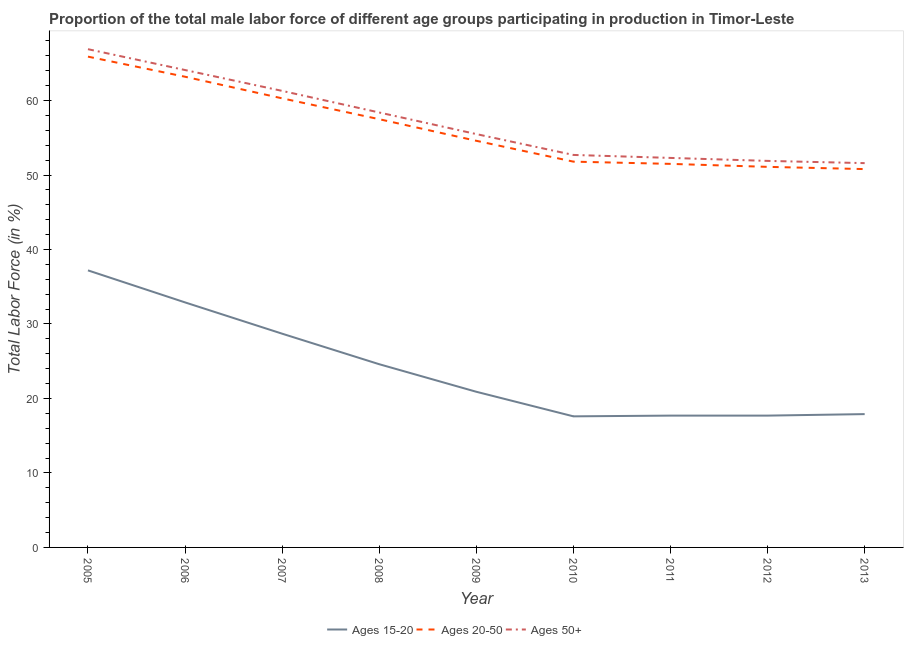Does the line corresponding to percentage of male labor force within the age group 20-50 intersect with the line corresponding to percentage of male labor force above age 50?
Your answer should be very brief. No. What is the percentage of male labor force within the age group 15-20 in 2013?
Provide a short and direct response. 17.9. Across all years, what is the maximum percentage of male labor force above age 50?
Your answer should be compact. 66.9. Across all years, what is the minimum percentage of male labor force above age 50?
Offer a terse response. 51.6. In which year was the percentage of male labor force within the age group 15-20 maximum?
Ensure brevity in your answer.  2005. In which year was the percentage of male labor force above age 50 minimum?
Make the answer very short. 2013. What is the total percentage of male labor force within the age group 15-20 in the graph?
Offer a very short reply. 215.2. What is the difference between the percentage of male labor force within the age group 15-20 in 2006 and that in 2010?
Your response must be concise. 15.3. What is the difference between the percentage of male labor force above age 50 in 2007 and the percentage of male labor force within the age group 15-20 in 2009?
Your answer should be very brief. 40.4. What is the average percentage of male labor force within the age group 15-20 per year?
Your answer should be compact. 23.91. In the year 2011, what is the difference between the percentage of male labor force above age 50 and percentage of male labor force within the age group 15-20?
Give a very brief answer. 34.6. What is the ratio of the percentage of male labor force above age 50 in 2008 to that in 2009?
Make the answer very short. 1.05. Is the percentage of male labor force above age 50 in 2005 less than that in 2006?
Give a very brief answer. No. What is the difference between the highest and the second highest percentage of male labor force within the age group 15-20?
Give a very brief answer. 4.3. What is the difference between the highest and the lowest percentage of male labor force above age 50?
Your answer should be very brief. 15.3. Is the percentage of male labor force within the age group 20-50 strictly greater than the percentage of male labor force within the age group 15-20 over the years?
Your response must be concise. Yes. How many lines are there?
Offer a terse response. 3. What is the difference between two consecutive major ticks on the Y-axis?
Make the answer very short. 10. Are the values on the major ticks of Y-axis written in scientific E-notation?
Your answer should be compact. No. Does the graph contain grids?
Offer a terse response. No. What is the title of the graph?
Ensure brevity in your answer.  Proportion of the total male labor force of different age groups participating in production in Timor-Leste. What is the Total Labor Force (in %) in Ages 15-20 in 2005?
Make the answer very short. 37.2. What is the Total Labor Force (in %) in Ages 20-50 in 2005?
Keep it short and to the point. 65.9. What is the Total Labor Force (in %) in Ages 50+ in 2005?
Offer a very short reply. 66.9. What is the Total Labor Force (in %) in Ages 15-20 in 2006?
Provide a succinct answer. 32.9. What is the Total Labor Force (in %) of Ages 20-50 in 2006?
Provide a short and direct response. 63.2. What is the Total Labor Force (in %) in Ages 50+ in 2006?
Provide a succinct answer. 64.1. What is the Total Labor Force (in %) of Ages 15-20 in 2007?
Keep it short and to the point. 28.7. What is the Total Labor Force (in %) in Ages 20-50 in 2007?
Keep it short and to the point. 60.3. What is the Total Labor Force (in %) of Ages 50+ in 2007?
Ensure brevity in your answer.  61.3. What is the Total Labor Force (in %) in Ages 15-20 in 2008?
Provide a short and direct response. 24.6. What is the Total Labor Force (in %) in Ages 20-50 in 2008?
Offer a very short reply. 57.5. What is the Total Labor Force (in %) of Ages 50+ in 2008?
Make the answer very short. 58.4. What is the Total Labor Force (in %) in Ages 15-20 in 2009?
Your answer should be very brief. 20.9. What is the Total Labor Force (in %) of Ages 20-50 in 2009?
Ensure brevity in your answer.  54.6. What is the Total Labor Force (in %) of Ages 50+ in 2009?
Offer a very short reply. 55.5. What is the Total Labor Force (in %) of Ages 15-20 in 2010?
Keep it short and to the point. 17.6. What is the Total Labor Force (in %) in Ages 20-50 in 2010?
Give a very brief answer. 51.8. What is the Total Labor Force (in %) in Ages 50+ in 2010?
Your answer should be very brief. 52.7. What is the Total Labor Force (in %) in Ages 15-20 in 2011?
Your answer should be compact. 17.7. What is the Total Labor Force (in %) of Ages 20-50 in 2011?
Your answer should be very brief. 51.5. What is the Total Labor Force (in %) in Ages 50+ in 2011?
Your answer should be compact. 52.3. What is the Total Labor Force (in %) in Ages 15-20 in 2012?
Keep it short and to the point. 17.7. What is the Total Labor Force (in %) of Ages 20-50 in 2012?
Keep it short and to the point. 51.1. What is the Total Labor Force (in %) of Ages 50+ in 2012?
Your answer should be very brief. 51.9. What is the Total Labor Force (in %) in Ages 15-20 in 2013?
Offer a very short reply. 17.9. What is the Total Labor Force (in %) in Ages 20-50 in 2013?
Your answer should be very brief. 50.8. What is the Total Labor Force (in %) of Ages 50+ in 2013?
Ensure brevity in your answer.  51.6. Across all years, what is the maximum Total Labor Force (in %) in Ages 15-20?
Offer a terse response. 37.2. Across all years, what is the maximum Total Labor Force (in %) in Ages 20-50?
Offer a very short reply. 65.9. Across all years, what is the maximum Total Labor Force (in %) in Ages 50+?
Give a very brief answer. 66.9. Across all years, what is the minimum Total Labor Force (in %) in Ages 15-20?
Provide a succinct answer. 17.6. Across all years, what is the minimum Total Labor Force (in %) of Ages 20-50?
Keep it short and to the point. 50.8. Across all years, what is the minimum Total Labor Force (in %) in Ages 50+?
Give a very brief answer. 51.6. What is the total Total Labor Force (in %) of Ages 15-20 in the graph?
Your answer should be very brief. 215.2. What is the total Total Labor Force (in %) in Ages 20-50 in the graph?
Provide a succinct answer. 506.7. What is the total Total Labor Force (in %) of Ages 50+ in the graph?
Give a very brief answer. 514.7. What is the difference between the Total Labor Force (in %) of Ages 20-50 in 2005 and that in 2006?
Your answer should be compact. 2.7. What is the difference between the Total Labor Force (in %) of Ages 15-20 in 2005 and that in 2007?
Your answer should be very brief. 8.5. What is the difference between the Total Labor Force (in %) of Ages 50+ in 2005 and that in 2007?
Give a very brief answer. 5.6. What is the difference between the Total Labor Force (in %) in Ages 15-20 in 2005 and that in 2008?
Offer a very short reply. 12.6. What is the difference between the Total Labor Force (in %) of Ages 20-50 in 2005 and that in 2008?
Provide a short and direct response. 8.4. What is the difference between the Total Labor Force (in %) of Ages 50+ in 2005 and that in 2008?
Offer a very short reply. 8.5. What is the difference between the Total Labor Force (in %) of Ages 15-20 in 2005 and that in 2009?
Your answer should be compact. 16.3. What is the difference between the Total Labor Force (in %) in Ages 15-20 in 2005 and that in 2010?
Offer a very short reply. 19.6. What is the difference between the Total Labor Force (in %) in Ages 15-20 in 2005 and that in 2011?
Your answer should be very brief. 19.5. What is the difference between the Total Labor Force (in %) of Ages 20-50 in 2005 and that in 2011?
Make the answer very short. 14.4. What is the difference between the Total Labor Force (in %) of Ages 50+ in 2005 and that in 2011?
Make the answer very short. 14.6. What is the difference between the Total Labor Force (in %) in Ages 15-20 in 2005 and that in 2012?
Give a very brief answer. 19.5. What is the difference between the Total Labor Force (in %) of Ages 20-50 in 2005 and that in 2012?
Offer a terse response. 14.8. What is the difference between the Total Labor Force (in %) of Ages 50+ in 2005 and that in 2012?
Make the answer very short. 15. What is the difference between the Total Labor Force (in %) in Ages 15-20 in 2005 and that in 2013?
Your response must be concise. 19.3. What is the difference between the Total Labor Force (in %) of Ages 15-20 in 2006 and that in 2007?
Provide a short and direct response. 4.2. What is the difference between the Total Labor Force (in %) in Ages 20-50 in 2006 and that in 2007?
Keep it short and to the point. 2.9. What is the difference between the Total Labor Force (in %) of Ages 50+ in 2006 and that in 2007?
Offer a very short reply. 2.8. What is the difference between the Total Labor Force (in %) in Ages 20-50 in 2006 and that in 2009?
Make the answer very short. 8.6. What is the difference between the Total Labor Force (in %) in Ages 50+ in 2006 and that in 2009?
Your answer should be compact. 8.6. What is the difference between the Total Labor Force (in %) in Ages 15-20 in 2006 and that in 2010?
Give a very brief answer. 15.3. What is the difference between the Total Labor Force (in %) of Ages 20-50 in 2006 and that in 2010?
Your answer should be very brief. 11.4. What is the difference between the Total Labor Force (in %) of Ages 15-20 in 2006 and that in 2011?
Make the answer very short. 15.2. What is the difference between the Total Labor Force (in %) in Ages 15-20 in 2006 and that in 2012?
Make the answer very short. 15.2. What is the difference between the Total Labor Force (in %) of Ages 20-50 in 2006 and that in 2012?
Make the answer very short. 12.1. What is the difference between the Total Labor Force (in %) of Ages 50+ in 2006 and that in 2012?
Your answer should be very brief. 12.2. What is the difference between the Total Labor Force (in %) in Ages 15-20 in 2007 and that in 2008?
Provide a short and direct response. 4.1. What is the difference between the Total Labor Force (in %) in Ages 15-20 in 2007 and that in 2009?
Your response must be concise. 7.8. What is the difference between the Total Labor Force (in %) in Ages 15-20 in 2007 and that in 2010?
Offer a terse response. 11.1. What is the difference between the Total Labor Force (in %) in Ages 20-50 in 2007 and that in 2010?
Make the answer very short. 8.5. What is the difference between the Total Labor Force (in %) in Ages 50+ in 2007 and that in 2010?
Your response must be concise. 8.6. What is the difference between the Total Labor Force (in %) in Ages 20-50 in 2007 and that in 2011?
Provide a short and direct response. 8.8. What is the difference between the Total Labor Force (in %) in Ages 50+ in 2007 and that in 2011?
Ensure brevity in your answer.  9. What is the difference between the Total Labor Force (in %) in Ages 15-20 in 2007 and that in 2012?
Your answer should be compact. 11. What is the difference between the Total Labor Force (in %) of Ages 50+ in 2007 and that in 2012?
Provide a short and direct response. 9.4. What is the difference between the Total Labor Force (in %) in Ages 20-50 in 2007 and that in 2013?
Ensure brevity in your answer.  9.5. What is the difference between the Total Labor Force (in %) of Ages 50+ in 2007 and that in 2013?
Offer a terse response. 9.7. What is the difference between the Total Labor Force (in %) of Ages 15-20 in 2008 and that in 2009?
Keep it short and to the point. 3.7. What is the difference between the Total Labor Force (in %) of Ages 20-50 in 2008 and that in 2009?
Provide a short and direct response. 2.9. What is the difference between the Total Labor Force (in %) in Ages 20-50 in 2008 and that in 2011?
Your answer should be very brief. 6. What is the difference between the Total Labor Force (in %) in Ages 20-50 in 2008 and that in 2012?
Your response must be concise. 6.4. What is the difference between the Total Labor Force (in %) of Ages 50+ in 2008 and that in 2012?
Your response must be concise. 6.5. What is the difference between the Total Labor Force (in %) in Ages 20-50 in 2008 and that in 2013?
Your answer should be very brief. 6.7. What is the difference between the Total Labor Force (in %) of Ages 50+ in 2008 and that in 2013?
Ensure brevity in your answer.  6.8. What is the difference between the Total Labor Force (in %) in Ages 20-50 in 2009 and that in 2010?
Keep it short and to the point. 2.8. What is the difference between the Total Labor Force (in %) of Ages 20-50 in 2009 and that in 2013?
Your answer should be compact. 3.8. What is the difference between the Total Labor Force (in %) of Ages 50+ in 2009 and that in 2013?
Your answer should be very brief. 3.9. What is the difference between the Total Labor Force (in %) in Ages 20-50 in 2010 and that in 2011?
Offer a very short reply. 0.3. What is the difference between the Total Labor Force (in %) of Ages 15-20 in 2010 and that in 2012?
Your answer should be very brief. -0.1. What is the difference between the Total Labor Force (in %) of Ages 50+ in 2010 and that in 2012?
Your answer should be compact. 0.8. What is the difference between the Total Labor Force (in %) in Ages 20-50 in 2010 and that in 2013?
Offer a very short reply. 1. What is the difference between the Total Labor Force (in %) of Ages 15-20 in 2011 and that in 2013?
Your answer should be very brief. -0.2. What is the difference between the Total Labor Force (in %) of Ages 20-50 in 2012 and that in 2013?
Offer a very short reply. 0.3. What is the difference between the Total Labor Force (in %) of Ages 50+ in 2012 and that in 2013?
Keep it short and to the point. 0.3. What is the difference between the Total Labor Force (in %) of Ages 15-20 in 2005 and the Total Labor Force (in %) of Ages 20-50 in 2006?
Keep it short and to the point. -26. What is the difference between the Total Labor Force (in %) in Ages 15-20 in 2005 and the Total Labor Force (in %) in Ages 50+ in 2006?
Make the answer very short. -26.9. What is the difference between the Total Labor Force (in %) in Ages 15-20 in 2005 and the Total Labor Force (in %) in Ages 20-50 in 2007?
Give a very brief answer. -23.1. What is the difference between the Total Labor Force (in %) in Ages 15-20 in 2005 and the Total Labor Force (in %) in Ages 50+ in 2007?
Your response must be concise. -24.1. What is the difference between the Total Labor Force (in %) of Ages 15-20 in 2005 and the Total Labor Force (in %) of Ages 20-50 in 2008?
Offer a terse response. -20.3. What is the difference between the Total Labor Force (in %) in Ages 15-20 in 2005 and the Total Labor Force (in %) in Ages 50+ in 2008?
Offer a very short reply. -21.2. What is the difference between the Total Labor Force (in %) in Ages 20-50 in 2005 and the Total Labor Force (in %) in Ages 50+ in 2008?
Give a very brief answer. 7.5. What is the difference between the Total Labor Force (in %) of Ages 15-20 in 2005 and the Total Labor Force (in %) of Ages 20-50 in 2009?
Your response must be concise. -17.4. What is the difference between the Total Labor Force (in %) of Ages 15-20 in 2005 and the Total Labor Force (in %) of Ages 50+ in 2009?
Offer a terse response. -18.3. What is the difference between the Total Labor Force (in %) in Ages 20-50 in 2005 and the Total Labor Force (in %) in Ages 50+ in 2009?
Offer a very short reply. 10.4. What is the difference between the Total Labor Force (in %) in Ages 15-20 in 2005 and the Total Labor Force (in %) in Ages 20-50 in 2010?
Give a very brief answer. -14.6. What is the difference between the Total Labor Force (in %) of Ages 15-20 in 2005 and the Total Labor Force (in %) of Ages 50+ in 2010?
Your answer should be very brief. -15.5. What is the difference between the Total Labor Force (in %) of Ages 20-50 in 2005 and the Total Labor Force (in %) of Ages 50+ in 2010?
Provide a succinct answer. 13.2. What is the difference between the Total Labor Force (in %) in Ages 15-20 in 2005 and the Total Labor Force (in %) in Ages 20-50 in 2011?
Provide a short and direct response. -14.3. What is the difference between the Total Labor Force (in %) in Ages 15-20 in 2005 and the Total Labor Force (in %) in Ages 50+ in 2011?
Give a very brief answer. -15.1. What is the difference between the Total Labor Force (in %) in Ages 15-20 in 2005 and the Total Labor Force (in %) in Ages 20-50 in 2012?
Provide a succinct answer. -13.9. What is the difference between the Total Labor Force (in %) of Ages 15-20 in 2005 and the Total Labor Force (in %) of Ages 50+ in 2012?
Your answer should be compact. -14.7. What is the difference between the Total Labor Force (in %) of Ages 20-50 in 2005 and the Total Labor Force (in %) of Ages 50+ in 2012?
Ensure brevity in your answer.  14. What is the difference between the Total Labor Force (in %) of Ages 15-20 in 2005 and the Total Labor Force (in %) of Ages 50+ in 2013?
Keep it short and to the point. -14.4. What is the difference between the Total Labor Force (in %) in Ages 15-20 in 2006 and the Total Labor Force (in %) in Ages 20-50 in 2007?
Your answer should be compact. -27.4. What is the difference between the Total Labor Force (in %) of Ages 15-20 in 2006 and the Total Labor Force (in %) of Ages 50+ in 2007?
Your response must be concise. -28.4. What is the difference between the Total Labor Force (in %) of Ages 15-20 in 2006 and the Total Labor Force (in %) of Ages 20-50 in 2008?
Your answer should be compact. -24.6. What is the difference between the Total Labor Force (in %) in Ages 15-20 in 2006 and the Total Labor Force (in %) in Ages 50+ in 2008?
Ensure brevity in your answer.  -25.5. What is the difference between the Total Labor Force (in %) of Ages 15-20 in 2006 and the Total Labor Force (in %) of Ages 20-50 in 2009?
Offer a very short reply. -21.7. What is the difference between the Total Labor Force (in %) of Ages 15-20 in 2006 and the Total Labor Force (in %) of Ages 50+ in 2009?
Offer a terse response. -22.6. What is the difference between the Total Labor Force (in %) of Ages 20-50 in 2006 and the Total Labor Force (in %) of Ages 50+ in 2009?
Your response must be concise. 7.7. What is the difference between the Total Labor Force (in %) in Ages 15-20 in 2006 and the Total Labor Force (in %) in Ages 20-50 in 2010?
Your answer should be compact. -18.9. What is the difference between the Total Labor Force (in %) of Ages 15-20 in 2006 and the Total Labor Force (in %) of Ages 50+ in 2010?
Your response must be concise. -19.8. What is the difference between the Total Labor Force (in %) in Ages 15-20 in 2006 and the Total Labor Force (in %) in Ages 20-50 in 2011?
Give a very brief answer. -18.6. What is the difference between the Total Labor Force (in %) of Ages 15-20 in 2006 and the Total Labor Force (in %) of Ages 50+ in 2011?
Offer a very short reply. -19.4. What is the difference between the Total Labor Force (in %) in Ages 15-20 in 2006 and the Total Labor Force (in %) in Ages 20-50 in 2012?
Your answer should be very brief. -18.2. What is the difference between the Total Labor Force (in %) in Ages 20-50 in 2006 and the Total Labor Force (in %) in Ages 50+ in 2012?
Offer a very short reply. 11.3. What is the difference between the Total Labor Force (in %) in Ages 15-20 in 2006 and the Total Labor Force (in %) in Ages 20-50 in 2013?
Provide a short and direct response. -17.9. What is the difference between the Total Labor Force (in %) of Ages 15-20 in 2006 and the Total Labor Force (in %) of Ages 50+ in 2013?
Keep it short and to the point. -18.7. What is the difference between the Total Labor Force (in %) of Ages 20-50 in 2006 and the Total Labor Force (in %) of Ages 50+ in 2013?
Make the answer very short. 11.6. What is the difference between the Total Labor Force (in %) in Ages 15-20 in 2007 and the Total Labor Force (in %) in Ages 20-50 in 2008?
Your answer should be very brief. -28.8. What is the difference between the Total Labor Force (in %) of Ages 15-20 in 2007 and the Total Labor Force (in %) of Ages 50+ in 2008?
Your answer should be very brief. -29.7. What is the difference between the Total Labor Force (in %) of Ages 15-20 in 2007 and the Total Labor Force (in %) of Ages 20-50 in 2009?
Your answer should be very brief. -25.9. What is the difference between the Total Labor Force (in %) in Ages 15-20 in 2007 and the Total Labor Force (in %) in Ages 50+ in 2009?
Make the answer very short. -26.8. What is the difference between the Total Labor Force (in %) in Ages 15-20 in 2007 and the Total Labor Force (in %) in Ages 20-50 in 2010?
Ensure brevity in your answer.  -23.1. What is the difference between the Total Labor Force (in %) in Ages 15-20 in 2007 and the Total Labor Force (in %) in Ages 50+ in 2010?
Provide a short and direct response. -24. What is the difference between the Total Labor Force (in %) of Ages 15-20 in 2007 and the Total Labor Force (in %) of Ages 20-50 in 2011?
Give a very brief answer. -22.8. What is the difference between the Total Labor Force (in %) of Ages 15-20 in 2007 and the Total Labor Force (in %) of Ages 50+ in 2011?
Give a very brief answer. -23.6. What is the difference between the Total Labor Force (in %) in Ages 15-20 in 2007 and the Total Labor Force (in %) in Ages 20-50 in 2012?
Provide a succinct answer. -22.4. What is the difference between the Total Labor Force (in %) of Ages 15-20 in 2007 and the Total Labor Force (in %) of Ages 50+ in 2012?
Your answer should be compact. -23.2. What is the difference between the Total Labor Force (in %) of Ages 15-20 in 2007 and the Total Labor Force (in %) of Ages 20-50 in 2013?
Offer a terse response. -22.1. What is the difference between the Total Labor Force (in %) of Ages 15-20 in 2007 and the Total Labor Force (in %) of Ages 50+ in 2013?
Offer a terse response. -22.9. What is the difference between the Total Labor Force (in %) in Ages 15-20 in 2008 and the Total Labor Force (in %) in Ages 50+ in 2009?
Your response must be concise. -30.9. What is the difference between the Total Labor Force (in %) of Ages 15-20 in 2008 and the Total Labor Force (in %) of Ages 20-50 in 2010?
Give a very brief answer. -27.2. What is the difference between the Total Labor Force (in %) of Ages 15-20 in 2008 and the Total Labor Force (in %) of Ages 50+ in 2010?
Offer a very short reply. -28.1. What is the difference between the Total Labor Force (in %) in Ages 15-20 in 2008 and the Total Labor Force (in %) in Ages 20-50 in 2011?
Give a very brief answer. -26.9. What is the difference between the Total Labor Force (in %) in Ages 15-20 in 2008 and the Total Labor Force (in %) in Ages 50+ in 2011?
Keep it short and to the point. -27.7. What is the difference between the Total Labor Force (in %) in Ages 15-20 in 2008 and the Total Labor Force (in %) in Ages 20-50 in 2012?
Your answer should be compact. -26.5. What is the difference between the Total Labor Force (in %) in Ages 15-20 in 2008 and the Total Labor Force (in %) in Ages 50+ in 2012?
Offer a terse response. -27.3. What is the difference between the Total Labor Force (in %) in Ages 20-50 in 2008 and the Total Labor Force (in %) in Ages 50+ in 2012?
Your response must be concise. 5.6. What is the difference between the Total Labor Force (in %) of Ages 15-20 in 2008 and the Total Labor Force (in %) of Ages 20-50 in 2013?
Provide a short and direct response. -26.2. What is the difference between the Total Labor Force (in %) in Ages 15-20 in 2009 and the Total Labor Force (in %) in Ages 20-50 in 2010?
Offer a terse response. -30.9. What is the difference between the Total Labor Force (in %) of Ages 15-20 in 2009 and the Total Labor Force (in %) of Ages 50+ in 2010?
Your answer should be very brief. -31.8. What is the difference between the Total Labor Force (in %) in Ages 15-20 in 2009 and the Total Labor Force (in %) in Ages 20-50 in 2011?
Your response must be concise. -30.6. What is the difference between the Total Labor Force (in %) in Ages 15-20 in 2009 and the Total Labor Force (in %) in Ages 50+ in 2011?
Provide a short and direct response. -31.4. What is the difference between the Total Labor Force (in %) of Ages 20-50 in 2009 and the Total Labor Force (in %) of Ages 50+ in 2011?
Offer a terse response. 2.3. What is the difference between the Total Labor Force (in %) of Ages 15-20 in 2009 and the Total Labor Force (in %) of Ages 20-50 in 2012?
Your response must be concise. -30.2. What is the difference between the Total Labor Force (in %) of Ages 15-20 in 2009 and the Total Labor Force (in %) of Ages 50+ in 2012?
Offer a terse response. -31. What is the difference between the Total Labor Force (in %) of Ages 20-50 in 2009 and the Total Labor Force (in %) of Ages 50+ in 2012?
Your answer should be very brief. 2.7. What is the difference between the Total Labor Force (in %) of Ages 15-20 in 2009 and the Total Labor Force (in %) of Ages 20-50 in 2013?
Give a very brief answer. -29.9. What is the difference between the Total Labor Force (in %) in Ages 15-20 in 2009 and the Total Labor Force (in %) in Ages 50+ in 2013?
Offer a terse response. -30.7. What is the difference between the Total Labor Force (in %) of Ages 15-20 in 2010 and the Total Labor Force (in %) of Ages 20-50 in 2011?
Offer a very short reply. -33.9. What is the difference between the Total Labor Force (in %) in Ages 15-20 in 2010 and the Total Labor Force (in %) in Ages 50+ in 2011?
Offer a terse response. -34.7. What is the difference between the Total Labor Force (in %) in Ages 20-50 in 2010 and the Total Labor Force (in %) in Ages 50+ in 2011?
Provide a succinct answer. -0.5. What is the difference between the Total Labor Force (in %) in Ages 15-20 in 2010 and the Total Labor Force (in %) in Ages 20-50 in 2012?
Provide a short and direct response. -33.5. What is the difference between the Total Labor Force (in %) of Ages 15-20 in 2010 and the Total Labor Force (in %) of Ages 50+ in 2012?
Give a very brief answer. -34.3. What is the difference between the Total Labor Force (in %) of Ages 20-50 in 2010 and the Total Labor Force (in %) of Ages 50+ in 2012?
Keep it short and to the point. -0.1. What is the difference between the Total Labor Force (in %) in Ages 15-20 in 2010 and the Total Labor Force (in %) in Ages 20-50 in 2013?
Provide a succinct answer. -33.2. What is the difference between the Total Labor Force (in %) of Ages 15-20 in 2010 and the Total Labor Force (in %) of Ages 50+ in 2013?
Your answer should be very brief. -34. What is the difference between the Total Labor Force (in %) of Ages 20-50 in 2010 and the Total Labor Force (in %) of Ages 50+ in 2013?
Your response must be concise. 0.2. What is the difference between the Total Labor Force (in %) in Ages 15-20 in 2011 and the Total Labor Force (in %) in Ages 20-50 in 2012?
Provide a short and direct response. -33.4. What is the difference between the Total Labor Force (in %) of Ages 15-20 in 2011 and the Total Labor Force (in %) of Ages 50+ in 2012?
Ensure brevity in your answer.  -34.2. What is the difference between the Total Labor Force (in %) of Ages 20-50 in 2011 and the Total Labor Force (in %) of Ages 50+ in 2012?
Make the answer very short. -0.4. What is the difference between the Total Labor Force (in %) in Ages 15-20 in 2011 and the Total Labor Force (in %) in Ages 20-50 in 2013?
Your answer should be very brief. -33.1. What is the difference between the Total Labor Force (in %) of Ages 15-20 in 2011 and the Total Labor Force (in %) of Ages 50+ in 2013?
Give a very brief answer. -33.9. What is the difference between the Total Labor Force (in %) in Ages 20-50 in 2011 and the Total Labor Force (in %) in Ages 50+ in 2013?
Provide a short and direct response. -0.1. What is the difference between the Total Labor Force (in %) in Ages 15-20 in 2012 and the Total Labor Force (in %) in Ages 20-50 in 2013?
Offer a terse response. -33.1. What is the difference between the Total Labor Force (in %) in Ages 15-20 in 2012 and the Total Labor Force (in %) in Ages 50+ in 2013?
Provide a succinct answer. -33.9. What is the difference between the Total Labor Force (in %) in Ages 20-50 in 2012 and the Total Labor Force (in %) in Ages 50+ in 2013?
Keep it short and to the point. -0.5. What is the average Total Labor Force (in %) in Ages 15-20 per year?
Provide a succinct answer. 23.91. What is the average Total Labor Force (in %) in Ages 20-50 per year?
Your answer should be compact. 56.3. What is the average Total Labor Force (in %) of Ages 50+ per year?
Offer a terse response. 57.19. In the year 2005, what is the difference between the Total Labor Force (in %) of Ages 15-20 and Total Labor Force (in %) of Ages 20-50?
Provide a succinct answer. -28.7. In the year 2005, what is the difference between the Total Labor Force (in %) of Ages 15-20 and Total Labor Force (in %) of Ages 50+?
Make the answer very short. -29.7. In the year 2006, what is the difference between the Total Labor Force (in %) of Ages 15-20 and Total Labor Force (in %) of Ages 20-50?
Your answer should be compact. -30.3. In the year 2006, what is the difference between the Total Labor Force (in %) in Ages 15-20 and Total Labor Force (in %) in Ages 50+?
Your answer should be compact. -31.2. In the year 2006, what is the difference between the Total Labor Force (in %) of Ages 20-50 and Total Labor Force (in %) of Ages 50+?
Offer a very short reply. -0.9. In the year 2007, what is the difference between the Total Labor Force (in %) of Ages 15-20 and Total Labor Force (in %) of Ages 20-50?
Your response must be concise. -31.6. In the year 2007, what is the difference between the Total Labor Force (in %) in Ages 15-20 and Total Labor Force (in %) in Ages 50+?
Provide a short and direct response. -32.6. In the year 2008, what is the difference between the Total Labor Force (in %) in Ages 15-20 and Total Labor Force (in %) in Ages 20-50?
Ensure brevity in your answer.  -32.9. In the year 2008, what is the difference between the Total Labor Force (in %) in Ages 15-20 and Total Labor Force (in %) in Ages 50+?
Provide a short and direct response. -33.8. In the year 2009, what is the difference between the Total Labor Force (in %) in Ages 15-20 and Total Labor Force (in %) in Ages 20-50?
Keep it short and to the point. -33.7. In the year 2009, what is the difference between the Total Labor Force (in %) in Ages 15-20 and Total Labor Force (in %) in Ages 50+?
Keep it short and to the point. -34.6. In the year 2010, what is the difference between the Total Labor Force (in %) of Ages 15-20 and Total Labor Force (in %) of Ages 20-50?
Offer a very short reply. -34.2. In the year 2010, what is the difference between the Total Labor Force (in %) in Ages 15-20 and Total Labor Force (in %) in Ages 50+?
Provide a short and direct response. -35.1. In the year 2010, what is the difference between the Total Labor Force (in %) in Ages 20-50 and Total Labor Force (in %) in Ages 50+?
Make the answer very short. -0.9. In the year 2011, what is the difference between the Total Labor Force (in %) in Ages 15-20 and Total Labor Force (in %) in Ages 20-50?
Offer a terse response. -33.8. In the year 2011, what is the difference between the Total Labor Force (in %) in Ages 15-20 and Total Labor Force (in %) in Ages 50+?
Give a very brief answer. -34.6. In the year 2012, what is the difference between the Total Labor Force (in %) of Ages 15-20 and Total Labor Force (in %) of Ages 20-50?
Offer a very short reply. -33.4. In the year 2012, what is the difference between the Total Labor Force (in %) in Ages 15-20 and Total Labor Force (in %) in Ages 50+?
Your answer should be compact. -34.2. In the year 2013, what is the difference between the Total Labor Force (in %) in Ages 15-20 and Total Labor Force (in %) in Ages 20-50?
Ensure brevity in your answer.  -32.9. In the year 2013, what is the difference between the Total Labor Force (in %) in Ages 15-20 and Total Labor Force (in %) in Ages 50+?
Ensure brevity in your answer.  -33.7. In the year 2013, what is the difference between the Total Labor Force (in %) in Ages 20-50 and Total Labor Force (in %) in Ages 50+?
Offer a very short reply. -0.8. What is the ratio of the Total Labor Force (in %) in Ages 15-20 in 2005 to that in 2006?
Your answer should be very brief. 1.13. What is the ratio of the Total Labor Force (in %) in Ages 20-50 in 2005 to that in 2006?
Your answer should be compact. 1.04. What is the ratio of the Total Labor Force (in %) of Ages 50+ in 2005 to that in 2006?
Keep it short and to the point. 1.04. What is the ratio of the Total Labor Force (in %) in Ages 15-20 in 2005 to that in 2007?
Provide a short and direct response. 1.3. What is the ratio of the Total Labor Force (in %) in Ages 20-50 in 2005 to that in 2007?
Give a very brief answer. 1.09. What is the ratio of the Total Labor Force (in %) of Ages 50+ in 2005 to that in 2007?
Provide a short and direct response. 1.09. What is the ratio of the Total Labor Force (in %) of Ages 15-20 in 2005 to that in 2008?
Your response must be concise. 1.51. What is the ratio of the Total Labor Force (in %) in Ages 20-50 in 2005 to that in 2008?
Provide a succinct answer. 1.15. What is the ratio of the Total Labor Force (in %) of Ages 50+ in 2005 to that in 2008?
Provide a succinct answer. 1.15. What is the ratio of the Total Labor Force (in %) in Ages 15-20 in 2005 to that in 2009?
Your response must be concise. 1.78. What is the ratio of the Total Labor Force (in %) of Ages 20-50 in 2005 to that in 2009?
Offer a terse response. 1.21. What is the ratio of the Total Labor Force (in %) in Ages 50+ in 2005 to that in 2009?
Provide a succinct answer. 1.21. What is the ratio of the Total Labor Force (in %) in Ages 15-20 in 2005 to that in 2010?
Provide a short and direct response. 2.11. What is the ratio of the Total Labor Force (in %) of Ages 20-50 in 2005 to that in 2010?
Ensure brevity in your answer.  1.27. What is the ratio of the Total Labor Force (in %) in Ages 50+ in 2005 to that in 2010?
Offer a very short reply. 1.27. What is the ratio of the Total Labor Force (in %) in Ages 15-20 in 2005 to that in 2011?
Keep it short and to the point. 2.1. What is the ratio of the Total Labor Force (in %) of Ages 20-50 in 2005 to that in 2011?
Your answer should be very brief. 1.28. What is the ratio of the Total Labor Force (in %) in Ages 50+ in 2005 to that in 2011?
Your response must be concise. 1.28. What is the ratio of the Total Labor Force (in %) of Ages 15-20 in 2005 to that in 2012?
Provide a succinct answer. 2.1. What is the ratio of the Total Labor Force (in %) in Ages 20-50 in 2005 to that in 2012?
Provide a succinct answer. 1.29. What is the ratio of the Total Labor Force (in %) of Ages 50+ in 2005 to that in 2012?
Keep it short and to the point. 1.29. What is the ratio of the Total Labor Force (in %) in Ages 15-20 in 2005 to that in 2013?
Make the answer very short. 2.08. What is the ratio of the Total Labor Force (in %) of Ages 20-50 in 2005 to that in 2013?
Give a very brief answer. 1.3. What is the ratio of the Total Labor Force (in %) of Ages 50+ in 2005 to that in 2013?
Give a very brief answer. 1.3. What is the ratio of the Total Labor Force (in %) of Ages 15-20 in 2006 to that in 2007?
Offer a terse response. 1.15. What is the ratio of the Total Labor Force (in %) in Ages 20-50 in 2006 to that in 2007?
Your answer should be compact. 1.05. What is the ratio of the Total Labor Force (in %) in Ages 50+ in 2006 to that in 2007?
Provide a short and direct response. 1.05. What is the ratio of the Total Labor Force (in %) in Ages 15-20 in 2006 to that in 2008?
Make the answer very short. 1.34. What is the ratio of the Total Labor Force (in %) of Ages 20-50 in 2006 to that in 2008?
Your answer should be compact. 1.1. What is the ratio of the Total Labor Force (in %) in Ages 50+ in 2006 to that in 2008?
Keep it short and to the point. 1.1. What is the ratio of the Total Labor Force (in %) of Ages 15-20 in 2006 to that in 2009?
Provide a succinct answer. 1.57. What is the ratio of the Total Labor Force (in %) of Ages 20-50 in 2006 to that in 2009?
Keep it short and to the point. 1.16. What is the ratio of the Total Labor Force (in %) of Ages 50+ in 2006 to that in 2009?
Provide a succinct answer. 1.16. What is the ratio of the Total Labor Force (in %) of Ages 15-20 in 2006 to that in 2010?
Provide a short and direct response. 1.87. What is the ratio of the Total Labor Force (in %) of Ages 20-50 in 2006 to that in 2010?
Ensure brevity in your answer.  1.22. What is the ratio of the Total Labor Force (in %) of Ages 50+ in 2006 to that in 2010?
Offer a terse response. 1.22. What is the ratio of the Total Labor Force (in %) in Ages 15-20 in 2006 to that in 2011?
Make the answer very short. 1.86. What is the ratio of the Total Labor Force (in %) in Ages 20-50 in 2006 to that in 2011?
Provide a succinct answer. 1.23. What is the ratio of the Total Labor Force (in %) of Ages 50+ in 2006 to that in 2011?
Offer a very short reply. 1.23. What is the ratio of the Total Labor Force (in %) of Ages 15-20 in 2006 to that in 2012?
Keep it short and to the point. 1.86. What is the ratio of the Total Labor Force (in %) in Ages 20-50 in 2006 to that in 2012?
Your response must be concise. 1.24. What is the ratio of the Total Labor Force (in %) in Ages 50+ in 2006 to that in 2012?
Your answer should be very brief. 1.24. What is the ratio of the Total Labor Force (in %) of Ages 15-20 in 2006 to that in 2013?
Offer a very short reply. 1.84. What is the ratio of the Total Labor Force (in %) in Ages 20-50 in 2006 to that in 2013?
Offer a terse response. 1.24. What is the ratio of the Total Labor Force (in %) of Ages 50+ in 2006 to that in 2013?
Your response must be concise. 1.24. What is the ratio of the Total Labor Force (in %) in Ages 20-50 in 2007 to that in 2008?
Provide a short and direct response. 1.05. What is the ratio of the Total Labor Force (in %) in Ages 50+ in 2007 to that in 2008?
Make the answer very short. 1.05. What is the ratio of the Total Labor Force (in %) in Ages 15-20 in 2007 to that in 2009?
Make the answer very short. 1.37. What is the ratio of the Total Labor Force (in %) of Ages 20-50 in 2007 to that in 2009?
Ensure brevity in your answer.  1.1. What is the ratio of the Total Labor Force (in %) of Ages 50+ in 2007 to that in 2009?
Provide a short and direct response. 1.1. What is the ratio of the Total Labor Force (in %) of Ages 15-20 in 2007 to that in 2010?
Your answer should be compact. 1.63. What is the ratio of the Total Labor Force (in %) in Ages 20-50 in 2007 to that in 2010?
Provide a short and direct response. 1.16. What is the ratio of the Total Labor Force (in %) of Ages 50+ in 2007 to that in 2010?
Offer a terse response. 1.16. What is the ratio of the Total Labor Force (in %) in Ages 15-20 in 2007 to that in 2011?
Ensure brevity in your answer.  1.62. What is the ratio of the Total Labor Force (in %) of Ages 20-50 in 2007 to that in 2011?
Provide a short and direct response. 1.17. What is the ratio of the Total Labor Force (in %) in Ages 50+ in 2007 to that in 2011?
Provide a succinct answer. 1.17. What is the ratio of the Total Labor Force (in %) of Ages 15-20 in 2007 to that in 2012?
Your answer should be compact. 1.62. What is the ratio of the Total Labor Force (in %) of Ages 20-50 in 2007 to that in 2012?
Keep it short and to the point. 1.18. What is the ratio of the Total Labor Force (in %) of Ages 50+ in 2007 to that in 2012?
Ensure brevity in your answer.  1.18. What is the ratio of the Total Labor Force (in %) of Ages 15-20 in 2007 to that in 2013?
Ensure brevity in your answer.  1.6. What is the ratio of the Total Labor Force (in %) of Ages 20-50 in 2007 to that in 2013?
Keep it short and to the point. 1.19. What is the ratio of the Total Labor Force (in %) in Ages 50+ in 2007 to that in 2013?
Your answer should be compact. 1.19. What is the ratio of the Total Labor Force (in %) in Ages 15-20 in 2008 to that in 2009?
Make the answer very short. 1.18. What is the ratio of the Total Labor Force (in %) in Ages 20-50 in 2008 to that in 2009?
Give a very brief answer. 1.05. What is the ratio of the Total Labor Force (in %) in Ages 50+ in 2008 to that in 2009?
Make the answer very short. 1.05. What is the ratio of the Total Labor Force (in %) in Ages 15-20 in 2008 to that in 2010?
Give a very brief answer. 1.4. What is the ratio of the Total Labor Force (in %) in Ages 20-50 in 2008 to that in 2010?
Provide a short and direct response. 1.11. What is the ratio of the Total Labor Force (in %) in Ages 50+ in 2008 to that in 2010?
Give a very brief answer. 1.11. What is the ratio of the Total Labor Force (in %) of Ages 15-20 in 2008 to that in 2011?
Provide a succinct answer. 1.39. What is the ratio of the Total Labor Force (in %) in Ages 20-50 in 2008 to that in 2011?
Make the answer very short. 1.12. What is the ratio of the Total Labor Force (in %) in Ages 50+ in 2008 to that in 2011?
Give a very brief answer. 1.12. What is the ratio of the Total Labor Force (in %) of Ages 15-20 in 2008 to that in 2012?
Offer a very short reply. 1.39. What is the ratio of the Total Labor Force (in %) of Ages 20-50 in 2008 to that in 2012?
Your response must be concise. 1.13. What is the ratio of the Total Labor Force (in %) in Ages 50+ in 2008 to that in 2012?
Your answer should be very brief. 1.13. What is the ratio of the Total Labor Force (in %) in Ages 15-20 in 2008 to that in 2013?
Make the answer very short. 1.37. What is the ratio of the Total Labor Force (in %) of Ages 20-50 in 2008 to that in 2013?
Provide a short and direct response. 1.13. What is the ratio of the Total Labor Force (in %) of Ages 50+ in 2008 to that in 2013?
Your response must be concise. 1.13. What is the ratio of the Total Labor Force (in %) in Ages 15-20 in 2009 to that in 2010?
Ensure brevity in your answer.  1.19. What is the ratio of the Total Labor Force (in %) of Ages 20-50 in 2009 to that in 2010?
Your answer should be compact. 1.05. What is the ratio of the Total Labor Force (in %) in Ages 50+ in 2009 to that in 2010?
Your answer should be compact. 1.05. What is the ratio of the Total Labor Force (in %) of Ages 15-20 in 2009 to that in 2011?
Offer a very short reply. 1.18. What is the ratio of the Total Labor Force (in %) of Ages 20-50 in 2009 to that in 2011?
Your response must be concise. 1.06. What is the ratio of the Total Labor Force (in %) in Ages 50+ in 2009 to that in 2011?
Ensure brevity in your answer.  1.06. What is the ratio of the Total Labor Force (in %) of Ages 15-20 in 2009 to that in 2012?
Ensure brevity in your answer.  1.18. What is the ratio of the Total Labor Force (in %) of Ages 20-50 in 2009 to that in 2012?
Make the answer very short. 1.07. What is the ratio of the Total Labor Force (in %) in Ages 50+ in 2009 to that in 2012?
Keep it short and to the point. 1.07. What is the ratio of the Total Labor Force (in %) of Ages 15-20 in 2009 to that in 2013?
Your response must be concise. 1.17. What is the ratio of the Total Labor Force (in %) of Ages 20-50 in 2009 to that in 2013?
Your response must be concise. 1.07. What is the ratio of the Total Labor Force (in %) of Ages 50+ in 2009 to that in 2013?
Provide a succinct answer. 1.08. What is the ratio of the Total Labor Force (in %) of Ages 20-50 in 2010 to that in 2011?
Your response must be concise. 1.01. What is the ratio of the Total Labor Force (in %) of Ages 50+ in 2010 to that in 2011?
Provide a short and direct response. 1.01. What is the ratio of the Total Labor Force (in %) in Ages 20-50 in 2010 to that in 2012?
Keep it short and to the point. 1.01. What is the ratio of the Total Labor Force (in %) in Ages 50+ in 2010 to that in 2012?
Provide a short and direct response. 1.02. What is the ratio of the Total Labor Force (in %) in Ages 15-20 in 2010 to that in 2013?
Make the answer very short. 0.98. What is the ratio of the Total Labor Force (in %) in Ages 20-50 in 2010 to that in 2013?
Keep it short and to the point. 1.02. What is the ratio of the Total Labor Force (in %) in Ages 50+ in 2010 to that in 2013?
Provide a succinct answer. 1.02. What is the ratio of the Total Labor Force (in %) in Ages 50+ in 2011 to that in 2012?
Offer a very short reply. 1.01. What is the ratio of the Total Labor Force (in %) in Ages 15-20 in 2011 to that in 2013?
Offer a very short reply. 0.99. What is the ratio of the Total Labor Force (in %) in Ages 20-50 in 2011 to that in 2013?
Offer a very short reply. 1.01. What is the ratio of the Total Labor Force (in %) in Ages 50+ in 2011 to that in 2013?
Offer a terse response. 1.01. What is the ratio of the Total Labor Force (in %) in Ages 15-20 in 2012 to that in 2013?
Offer a terse response. 0.99. What is the ratio of the Total Labor Force (in %) of Ages 20-50 in 2012 to that in 2013?
Give a very brief answer. 1.01. What is the difference between the highest and the second highest Total Labor Force (in %) in Ages 15-20?
Make the answer very short. 4.3. What is the difference between the highest and the second highest Total Labor Force (in %) in Ages 20-50?
Your response must be concise. 2.7. What is the difference between the highest and the second highest Total Labor Force (in %) of Ages 50+?
Provide a short and direct response. 2.8. What is the difference between the highest and the lowest Total Labor Force (in %) in Ages 15-20?
Provide a short and direct response. 19.6. What is the difference between the highest and the lowest Total Labor Force (in %) in Ages 20-50?
Your answer should be compact. 15.1. 